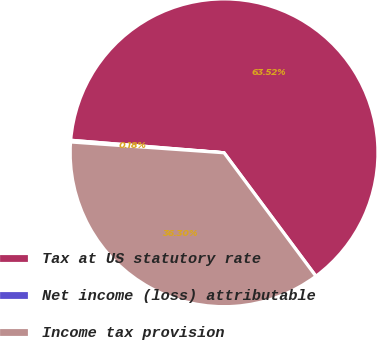Convert chart to OTSL. <chart><loc_0><loc_0><loc_500><loc_500><pie_chart><fcel>Tax at US statutory rate<fcel>Net income (loss) attributable<fcel>Income tax provision<nl><fcel>63.52%<fcel>0.18%<fcel>36.3%<nl></chart> 